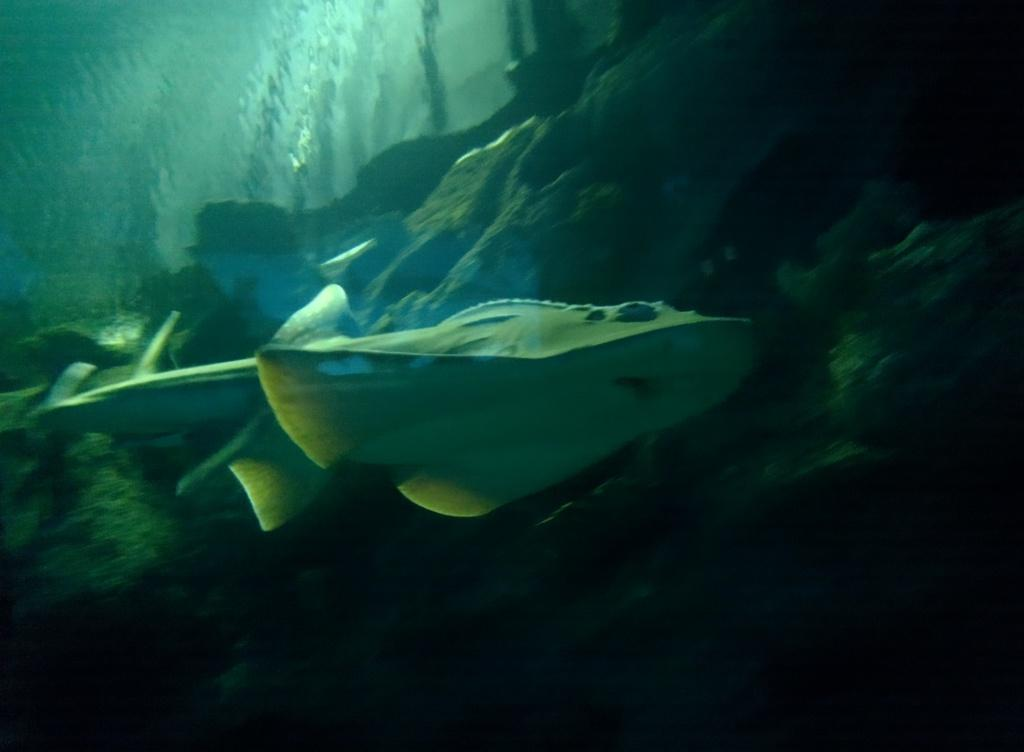What type of animal can be seen in the water in the image? There is a sea animal in the water in the image. What can be seen in the background of the image? There is a hill visible in the background of the image. What type of base can be seen supporting the coast in the image? There is no coast or base present in the image; it features a sea animal in the water and a hill in the background. 